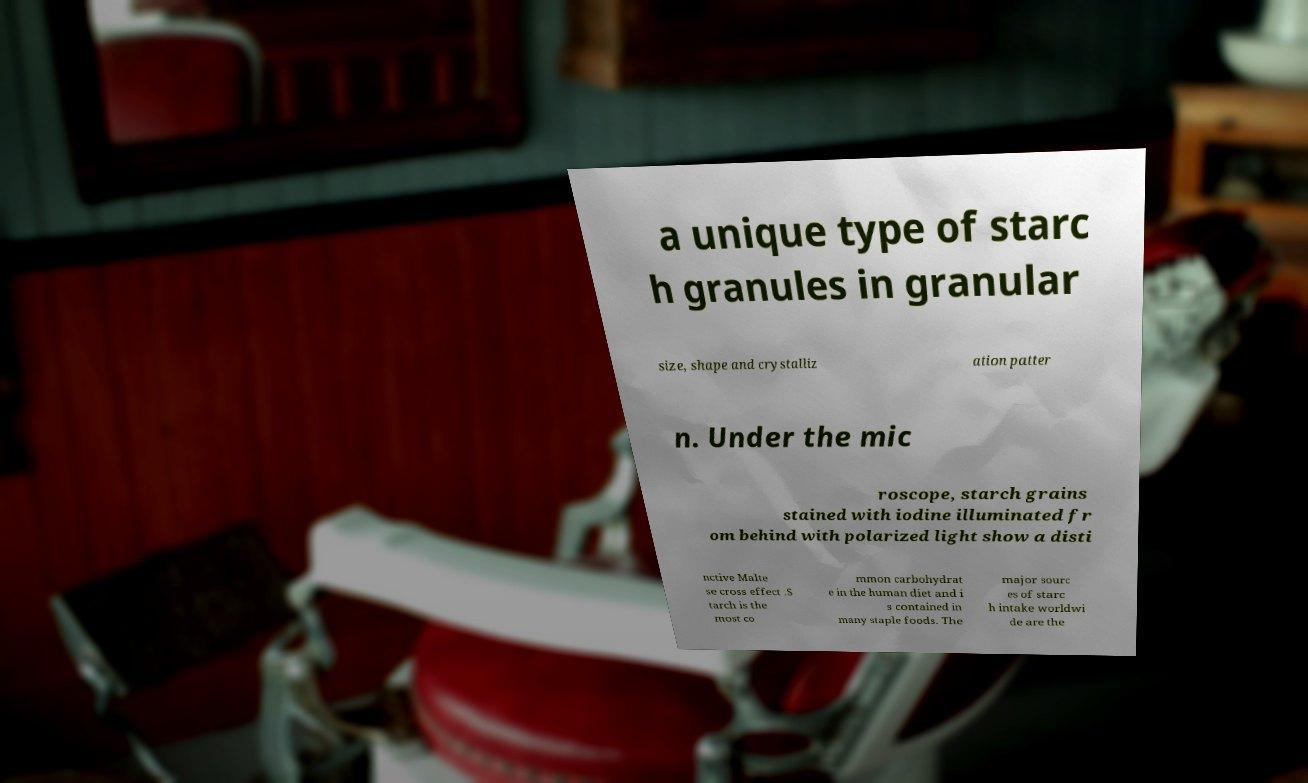Can you read and provide the text displayed in the image?This photo seems to have some interesting text. Can you extract and type it out for me? a unique type of starc h granules in granular size, shape and crystalliz ation patter n. Under the mic roscope, starch grains stained with iodine illuminated fr om behind with polarized light show a disti nctive Malte se cross effect .S tarch is the most co mmon carbohydrat e in the human diet and i s contained in many staple foods. The major sourc es of starc h intake worldwi de are the 